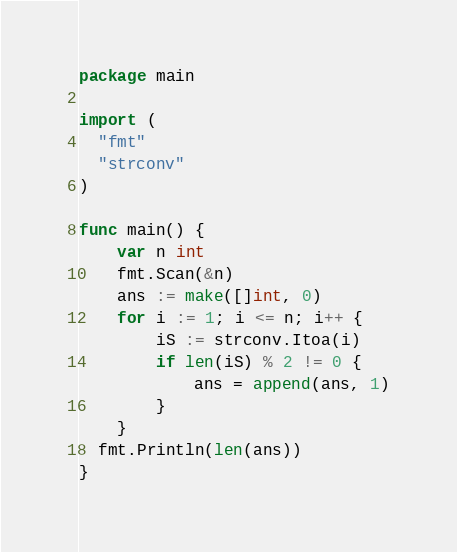<code> <loc_0><loc_0><loc_500><loc_500><_Go_>package main

import (
  "fmt"
  "strconv"
)

func main() {
	var n int
	fmt.Scan(&n)
  	ans := make([]int, 0)
	for i := 1; i <= n; i++ {
		iS := strconv.Itoa(i)
		if len(iS) % 2 != 0 {
			ans = append(ans, 1)
		}
	}
  fmt.Println(len(ans))
}

</code> 